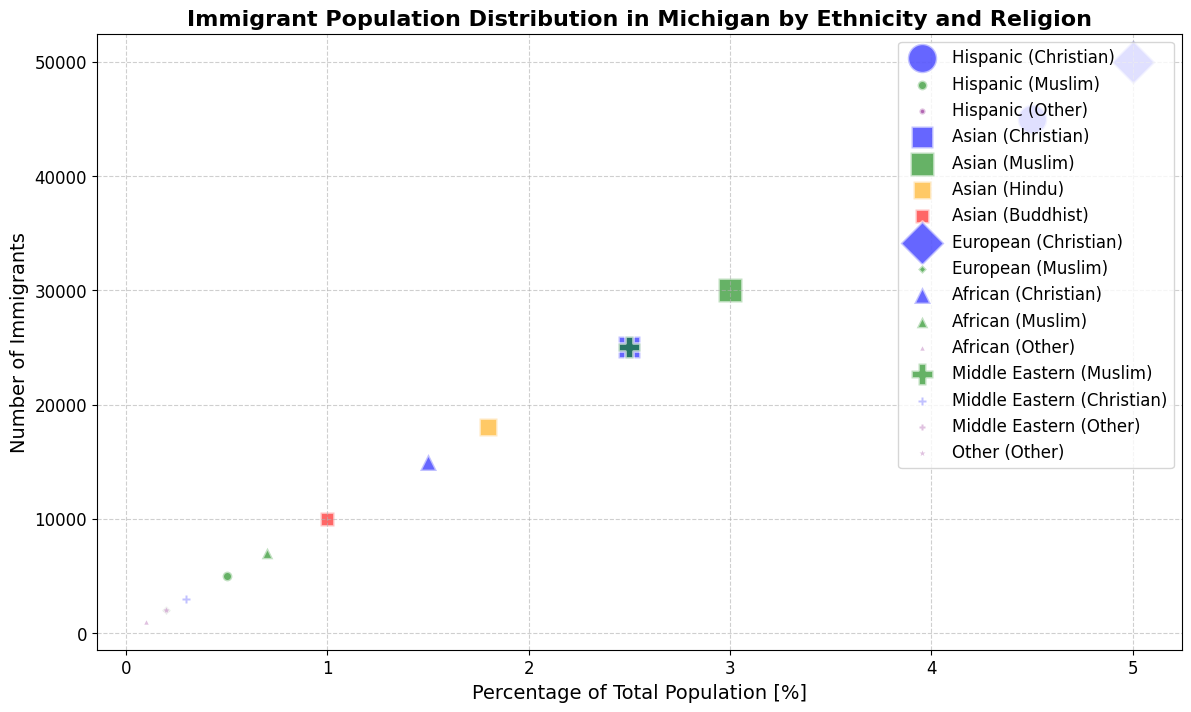What ethnicity and religion combination represents the largest percentage of the total population? The largest bubble on the x-axis represents the largest percentage of the total population. By looking at the size and position, the European Christian group at 5.0% seems to be the largest percentage.
Answer: European Christian Which ethnic group has the highest number of Muslim immigrants? Check the highest position on the y-axis among the green bubbles that represent Muslims. Both Asian Muslims and Middle Eastern Muslims seem high, but Middle Eastern Muslims are slightly higher at 25,000.
Answer: Middle Eastern What is the total number of Asian immigrants across all religions? Sum the number of immigrants from all Asian groups: Christian (25,000) + Muslim (30,000) + Hindu (18,000) + Buddhist (10,000). Total = 83,000.
Answer: 83,000 Which religious group among Hispanic immigrants has the lowest number of immigrants? Look for the smallest Hispanic bubble on the y-axis. The "Other" religious group has the smallest number with 2,000 immigrants.
Answer: Other Among African immigrants, which religion has the smallest representation? Find the smallest bubble among African groups on the y-axis. The "Other" religious group has the smallest number with 1,000 immigrants.
Answer: Other What is the difference in the number of immigrants between Asian Christians and Hispanic Christians? Subtract the number of Hispanic Christian immigrants (45,000) from Asian Christian immigrants (25,000). Difference = 25,000 - 45,000 = -20,000.
Answer: -20,000 Which religious group has the largest marker size among European immigrants? Evaluate the size of the bubbles for European categories. The European Christian group has the largest marker size with 50,000 immigrants.
Answer: Christian Is the percentage of Muslim immigrants higher in the Asian group or the Middle Eastern group? Compare the percentages on the x-axis: Asian Muslims (3.0%) and Middle Eastern Muslims (2.5%).
Answer: Asian How many total Christian immigrants are there excluding European Christians? Sum the number of Christian immigrants from Hispanic (45,000) + Asian (25,000) + African (15,000) + Middle Eastern (3,000). Total = 45,000 + 25,000 + 15,000 + 3,000 = 88,000.
Answer: 88,000 Which ethnicity has the smallest percentage of total population for their "Other" religion? Look at the smallest percentage value on the x-axis for the "Other" groups: Hispanic (0.2%), African (0.1%), Middle Eastern (0.2%), and unspecified "Other" (0.2%). The African "Other" group is the smallest at 0.1%.
Answer: African 